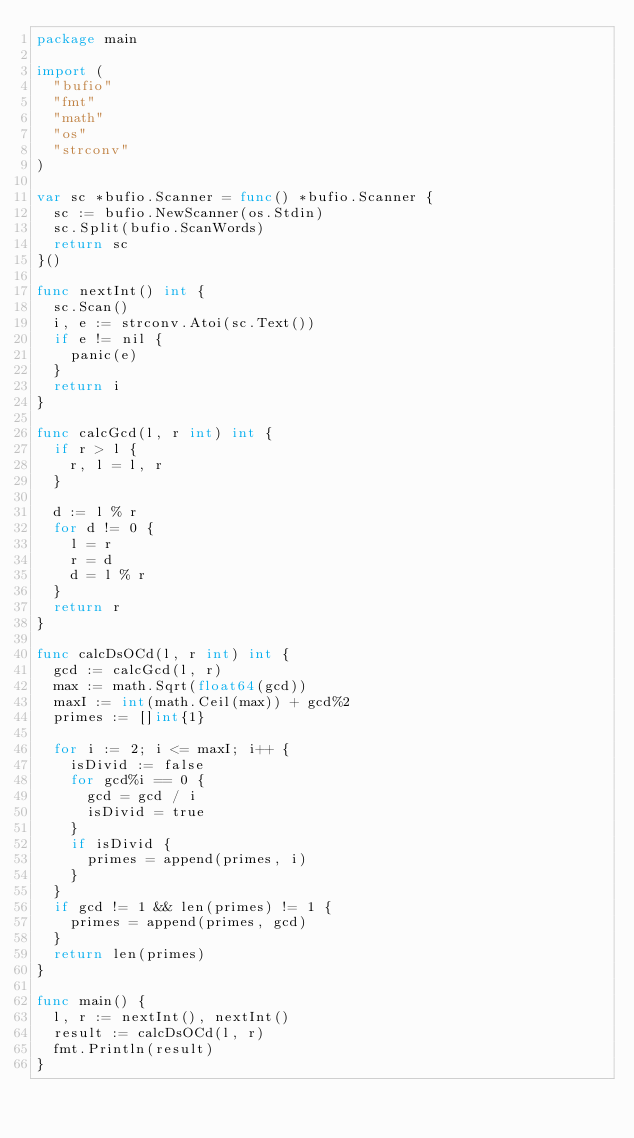<code> <loc_0><loc_0><loc_500><loc_500><_Go_>package main

import (
	"bufio"
	"fmt"
	"math"
	"os"
	"strconv"
)

var sc *bufio.Scanner = func() *bufio.Scanner {
	sc := bufio.NewScanner(os.Stdin)
	sc.Split(bufio.ScanWords)
	return sc
}()

func nextInt() int {
	sc.Scan()
	i, e := strconv.Atoi(sc.Text())
	if e != nil {
		panic(e)
	}
	return i
}

func calcGcd(l, r int) int {
	if r > l {
		r, l = l, r
	}

	d := l % r
	for d != 0 {
		l = r
		r = d
		d = l % r
	}
	return r
}

func calcDsOCd(l, r int) int {
	gcd := calcGcd(l, r)
	max := math.Sqrt(float64(gcd))
	maxI := int(math.Ceil(max)) + gcd%2
	primes := []int{1}

	for i := 2; i <= maxI; i++ {
		isDivid := false
		for gcd%i == 0 {
			gcd = gcd / i
			isDivid = true
		}
		if isDivid {
			primes = append(primes, i)
		}
	}
	if gcd != 1 && len(primes) != 1 {
		primes = append(primes, gcd)
	}
	return len(primes)
}

func main() {
	l, r := nextInt(), nextInt()
	result := calcDsOCd(l, r)
	fmt.Println(result)
}
</code> 